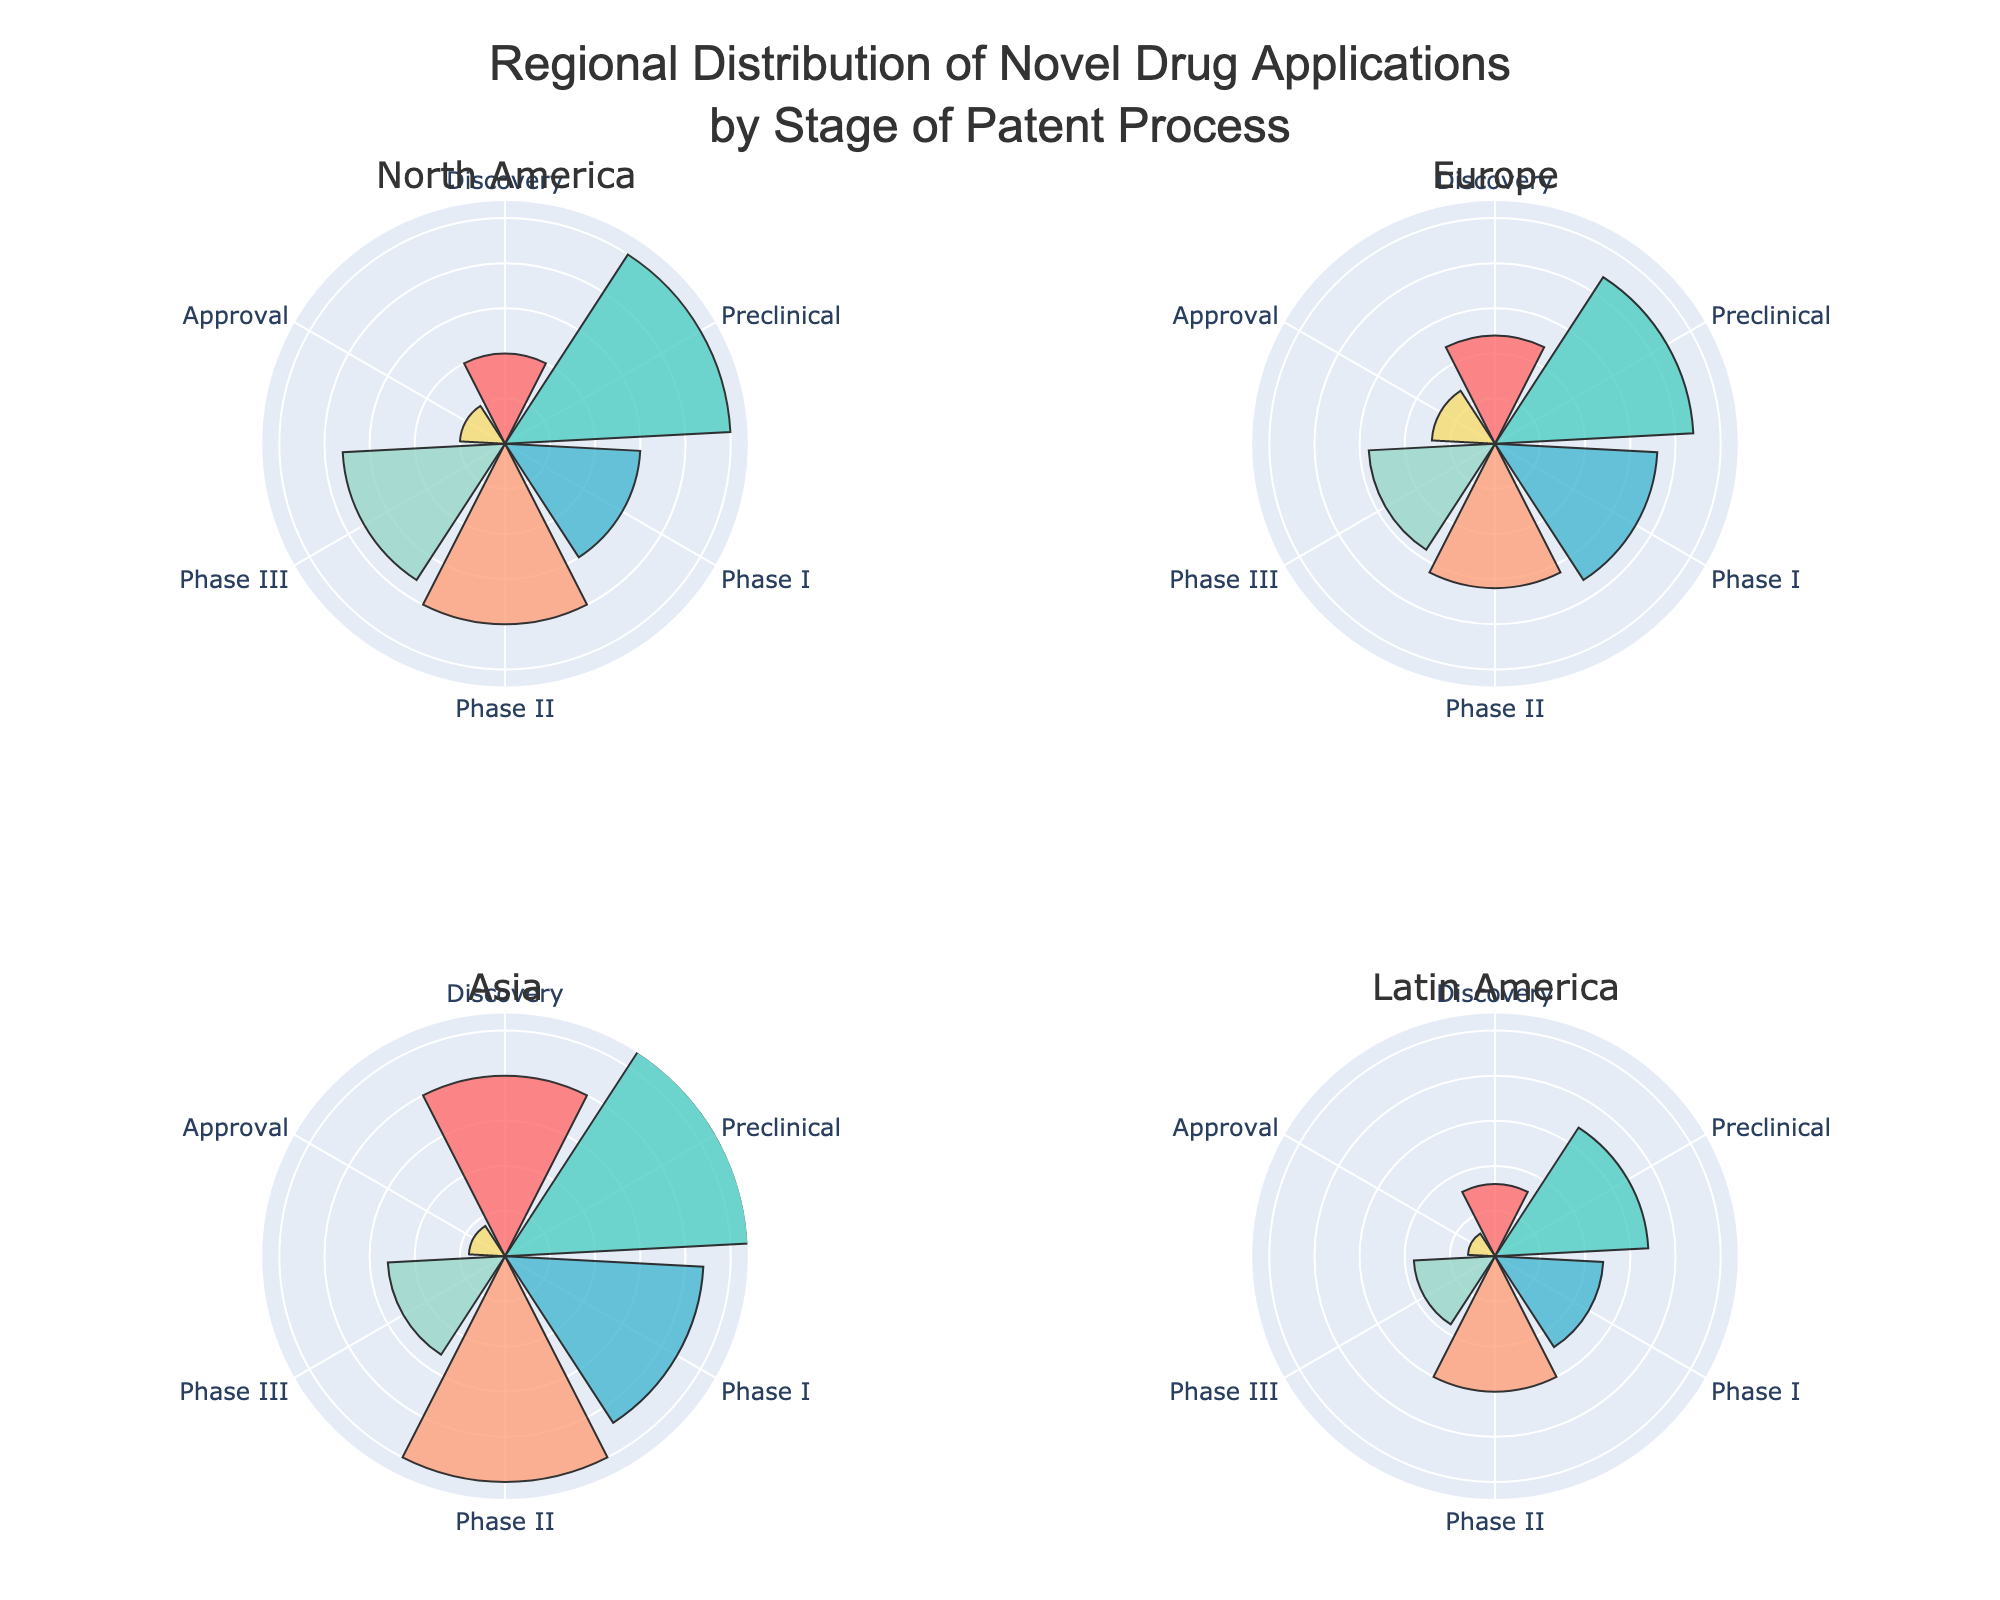What is the title of the figure? The title of the figure is prominently located at the top and readable without any interpretation required. It clearly states the topic being visualized.
Answer: "Regional Distribution of Novel Drug Applications by Stage of Patent Process" How many applications are in the Discovery stage in North America? The Discovery stage in North America is identified in the North America subplot, and the value can be read directly from the radial axis where the bar ends.
Answer: 10 Which region has the highest number of applications in the Preclinical stage? By examining the bars representing the Preclinical stage across all subplots, one can see which region's bar extends the furthest.
Answer: Asia Which two regions have the closest number of applications in the Phase II stage? By comparing the height of the bars for Phase II across all subplots, identifying the two regions where these bars are most similar leads to the answer.
Answer: Europe and Latin America What is the range of the radial axis? The range is determined by looking at the maximum value on the radial axis across any subplot. This range includes all the data points displayed in the figure.
Answer: 0 to 27 How many total applications are there in Europe across all stages? Summing up the application numbers for each stage in Europe by adding the numbers from the Discovery, Preclinical, Phase I, Phase II, Phase III, and Approval stages results in the total.
Answer: 89 Which region has the smallest number of applications in the Approval stage? By comparing the height of the bars representing the Approval stage, the region with the shortest bar represents the smallest number.
Answer: Latin America Are there more applications in Phase I or Phase III in North America? Comparing the heights of the bars for Phase I and Phase III shows which bar is taller, indicating a larger number.
Answer: Phase I What is the average number of applications in the Preclinical stage across all regions? Sum the number of applications for Preclinical stage across all regions (25 + 22 + 27 + 17 = 91) and then divide by the number of regions (4).
Answer: 22.75 